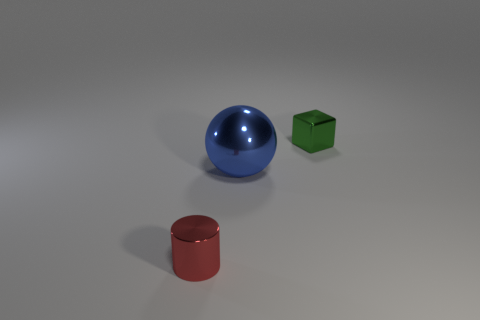What can you infer about the lighting source in this image? Observing the soft shadows and subtle highlights on the objects, it can be inferred that the lighting in this image is soft and diffused. There appears to be a single primary light source from above, slightly to the right, creating gentle, elongated shadows that add depth without being overly harsh. 